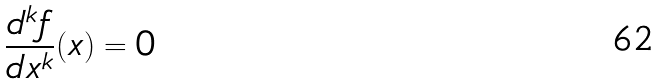<formula> <loc_0><loc_0><loc_500><loc_500>\frac { d ^ { k } f } { d x ^ { k } } ( x ) = 0</formula> 